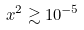<formula> <loc_0><loc_0><loc_500><loc_500>x ^ { 2 } \gtrsim 1 0 ^ { - 5 }</formula> 